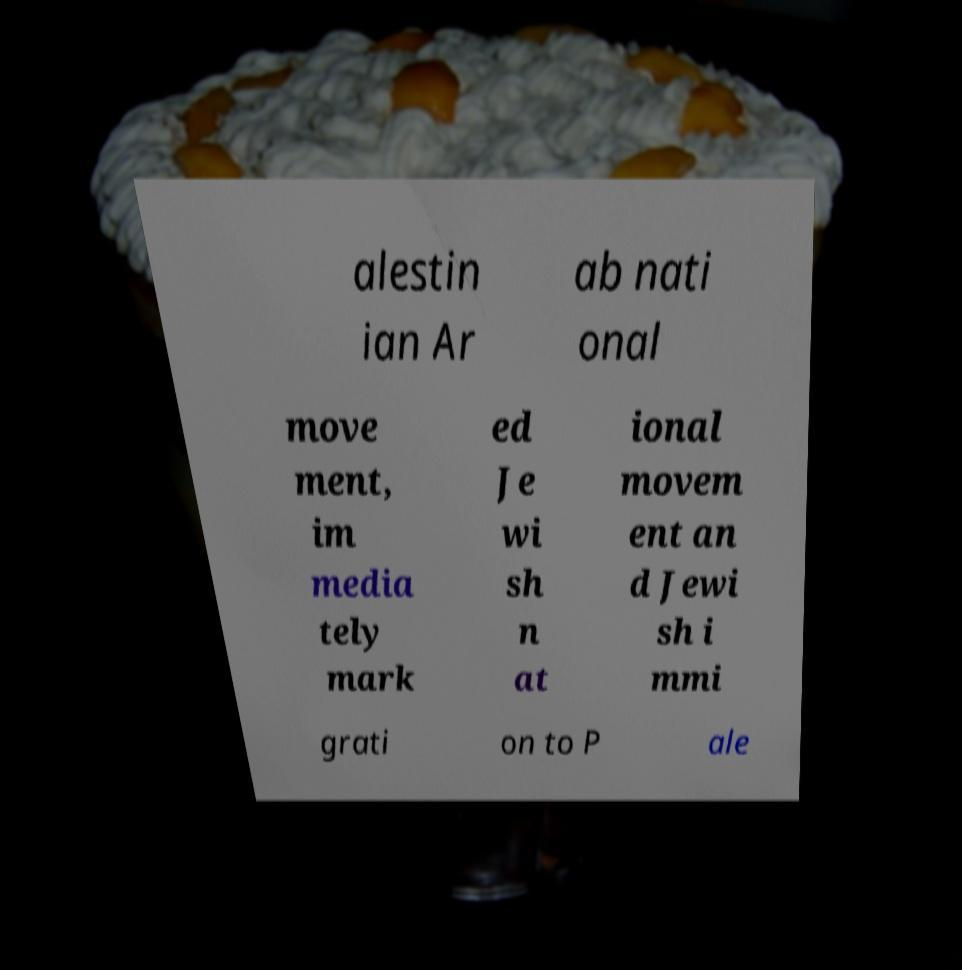There's text embedded in this image that I need extracted. Can you transcribe it verbatim? alestin ian Ar ab nati onal move ment, im media tely mark ed Je wi sh n at ional movem ent an d Jewi sh i mmi grati on to P ale 